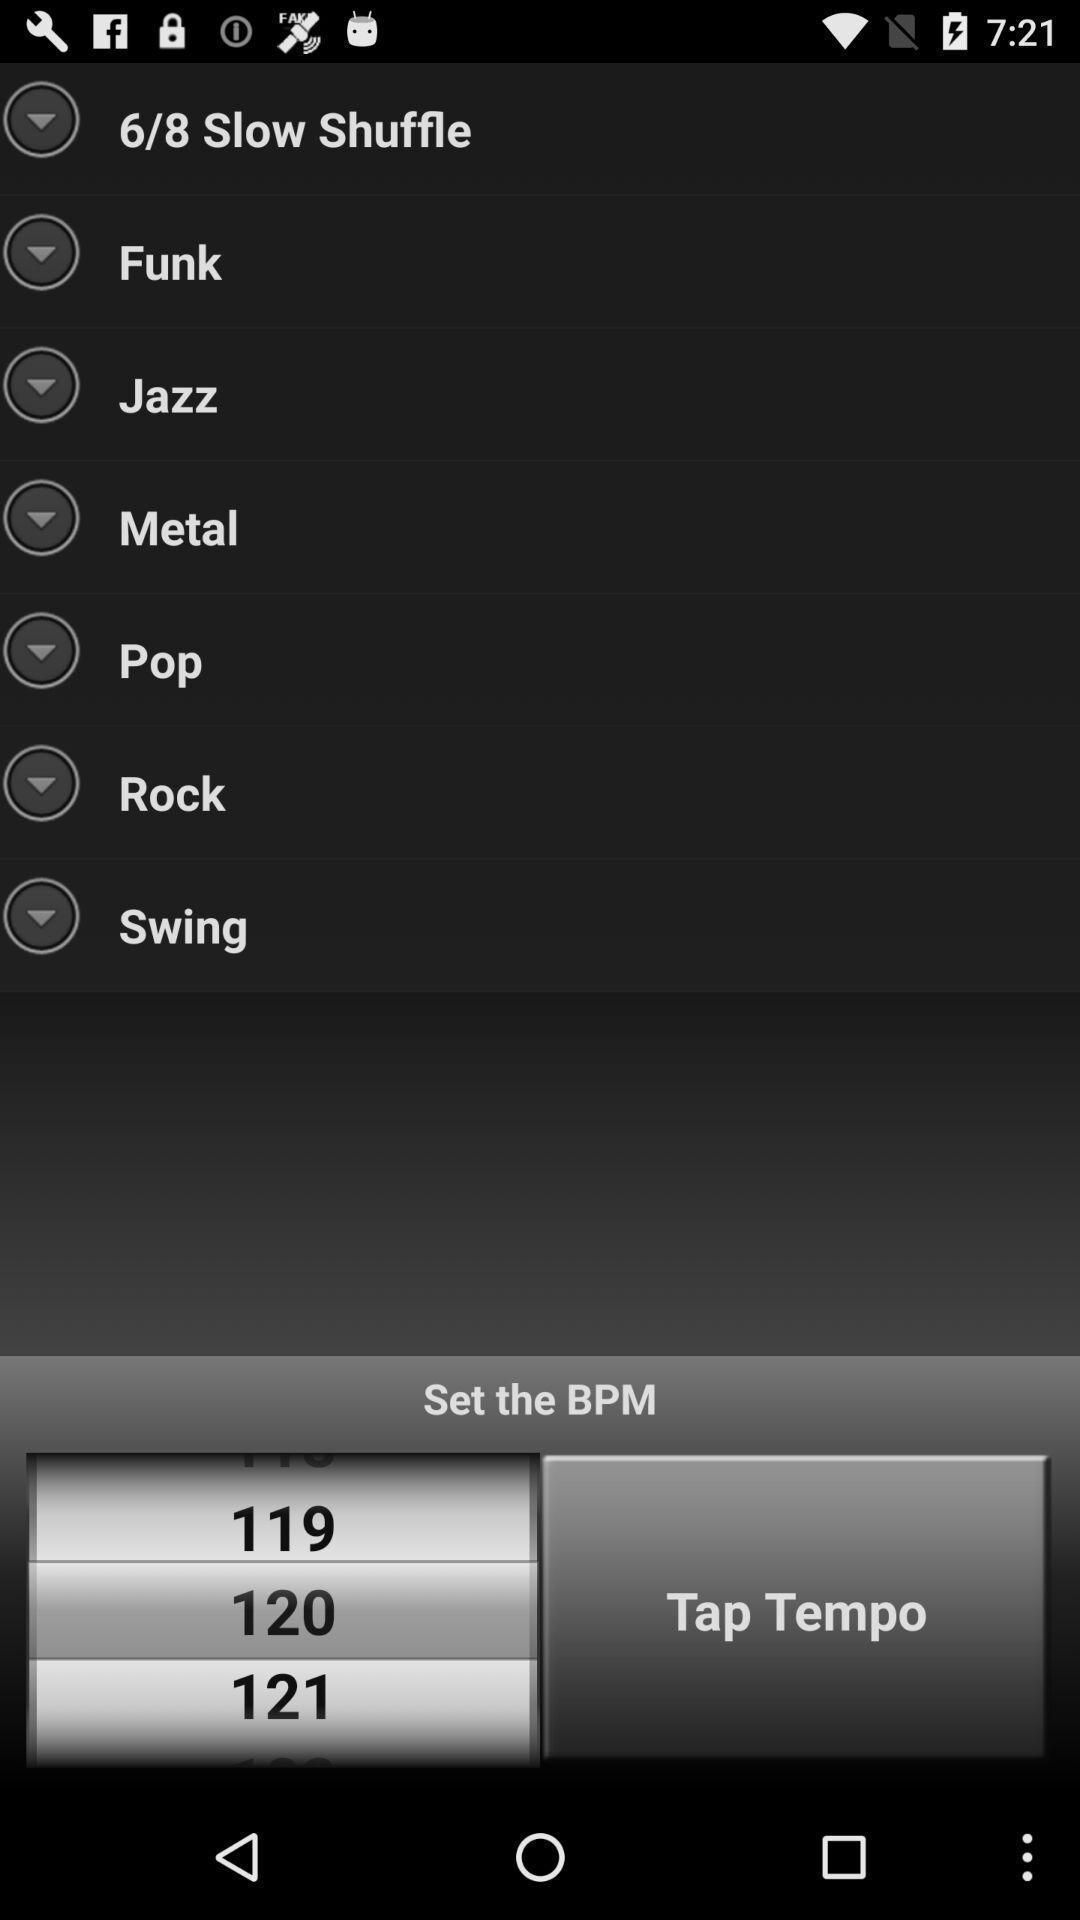Describe the key features of this screenshot. Screen displaying multiple style options in a music application. 